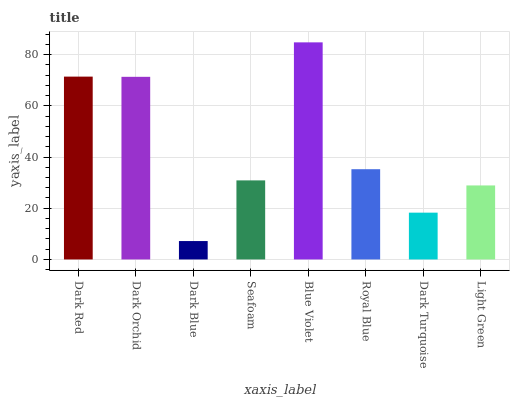Is Dark Orchid the minimum?
Answer yes or no. No. Is Dark Orchid the maximum?
Answer yes or no. No. Is Dark Red greater than Dark Orchid?
Answer yes or no. Yes. Is Dark Orchid less than Dark Red?
Answer yes or no. Yes. Is Dark Orchid greater than Dark Red?
Answer yes or no. No. Is Dark Red less than Dark Orchid?
Answer yes or no. No. Is Royal Blue the high median?
Answer yes or no. Yes. Is Seafoam the low median?
Answer yes or no. Yes. Is Dark Red the high median?
Answer yes or no. No. Is Royal Blue the low median?
Answer yes or no. No. 